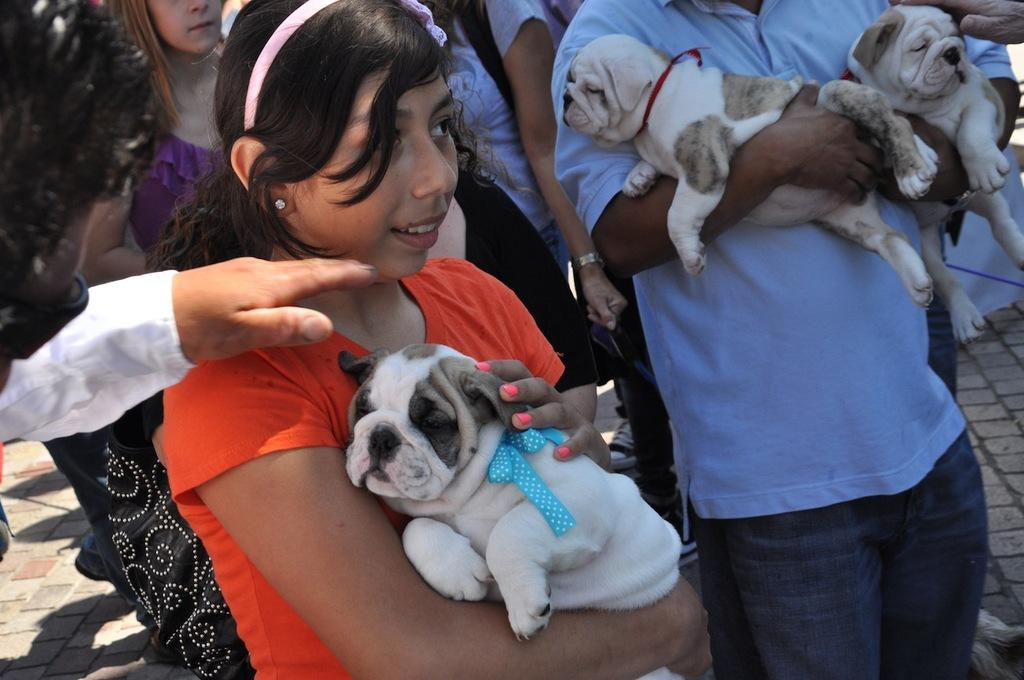What is happening in the image involving the persons? There are persons standing in the image, including a child holding a dog and a person standing beside the child. What is the child doing with the dog? The child is standing and holding a dog. What is the person standing beside the child doing? The person is holding two dogs in his hands. What type of boat is visible in the image? There is no boat present in the image. Are any of the persons wearing a mask in the image? There is no mention of masks in the image, so it cannot be determined if any of the persons are wearing one. 